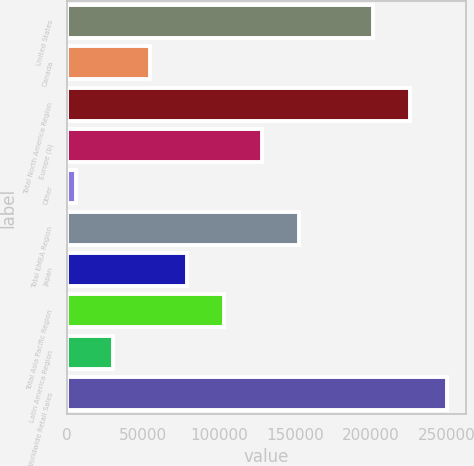<chart> <loc_0><loc_0><loc_500><loc_500><bar_chart><fcel>United States<fcel>Canada<fcel>Total North America Region<fcel>Europe (b)<fcel>Other<fcel>Total EMEA Region<fcel>Japan<fcel>Total Asia Pacific Region<fcel>Latin America Region<fcel>Total Worldwide Retail Sales<nl><fcel>201079<fcel>54769.8<fcel>225464<fcel>127924<fcel>6000<fcel>152309<fcel>79154.7<fcel>103540<fcel>30384.9<fcel>249849<nl></chart> 